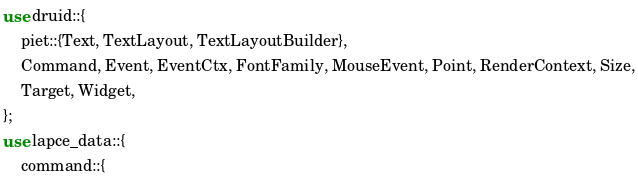Convert code to text. <code><loc_0><loc_0><loc_500><loc_500><_Rust_>use druid::{
    piet::{Text, TextLayout, TextLayoutBuilder},
    Command, Event, EventCtx, FontFamily, MouseEvent, Point, RenderContext, Size,
    Target, Widget,
};
use lapce_data::{
    command::{</code> 